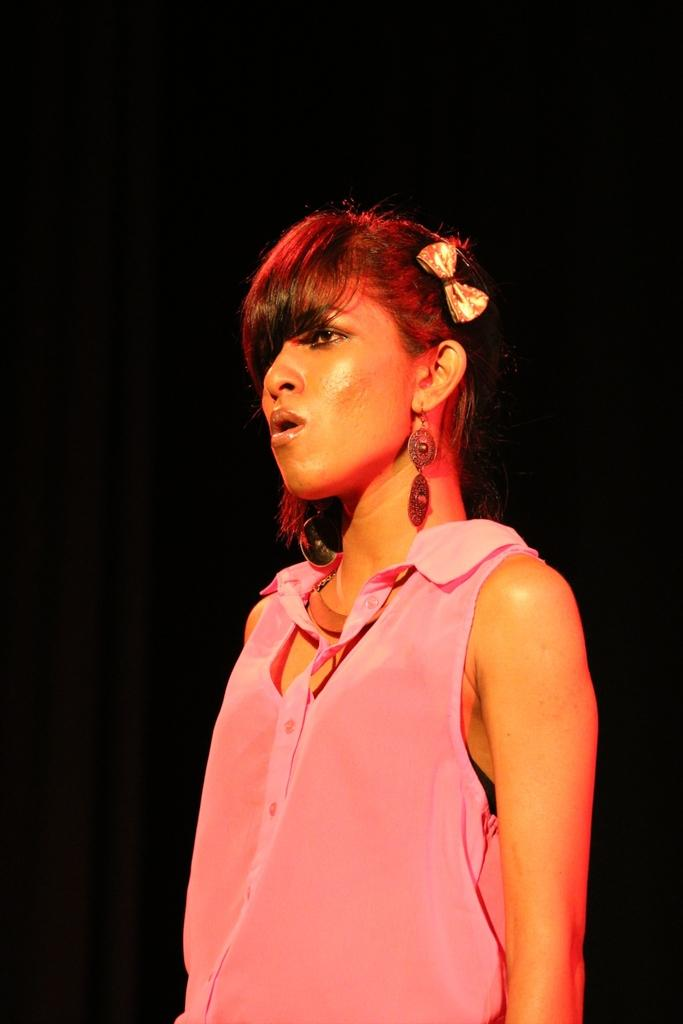What is the main subject of the image? There is a person standing in the image. What is the person wearing? The person is wearing a pink dress. What color is the background of the image? The background of the image is black. What type of sidewalk can be seen in the image? There is no sidewalk present in the image. What is the person feeling shame about in the image? There is no indication of shame or any emotion in the image; it only shows a person standing in a black background. 